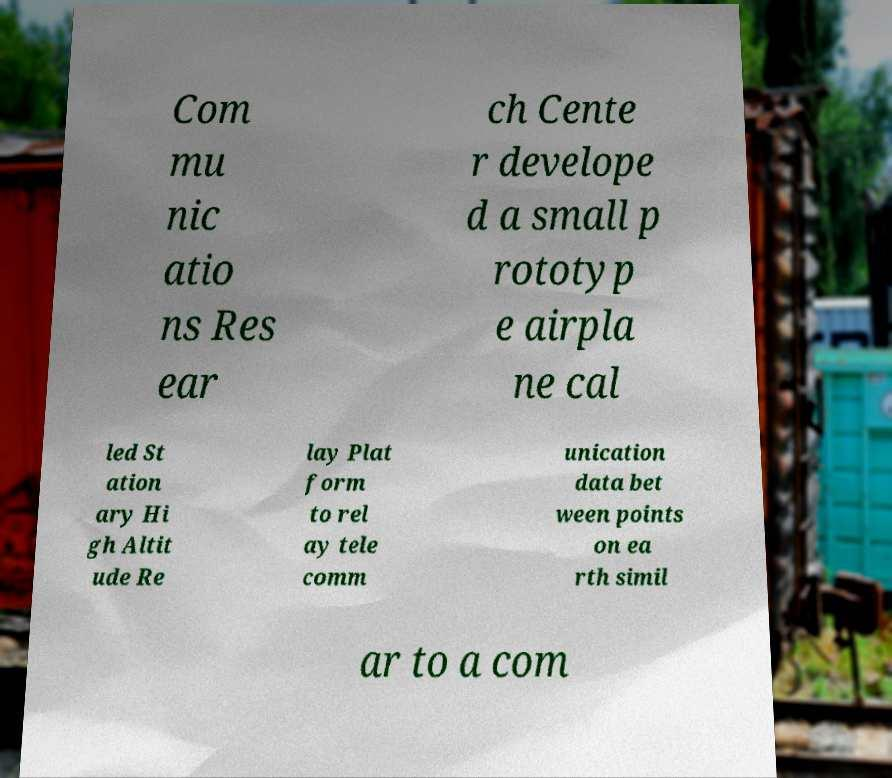Please identify and transcribe the text found in this image. Com mu nic atio ns Res ear ch Cente r develope d a small p rototyp e airpla ne cal led St ation ary Hi gh Altit ude Re lay Plat form to rel ay tele comm unication data bet ween points on ea rth simil ar to a com 